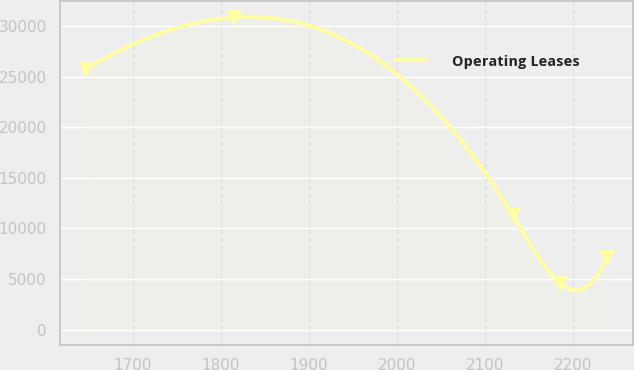Convert chart. <chart><loc_0><loc_0><loc_500><loc_500><line_chart><ecel><fcel>Operating Leases<nl><fcel>1646.94<fcel>25804.3<nl><fcel>1814.75<fcel>30895.3<nl><fcel>2132.05<fcel>11289.6<nl><fcel>2185.57<fcel>4594.26<nl><fcel>2239.09<fcel>7224.36<nl></chart> 